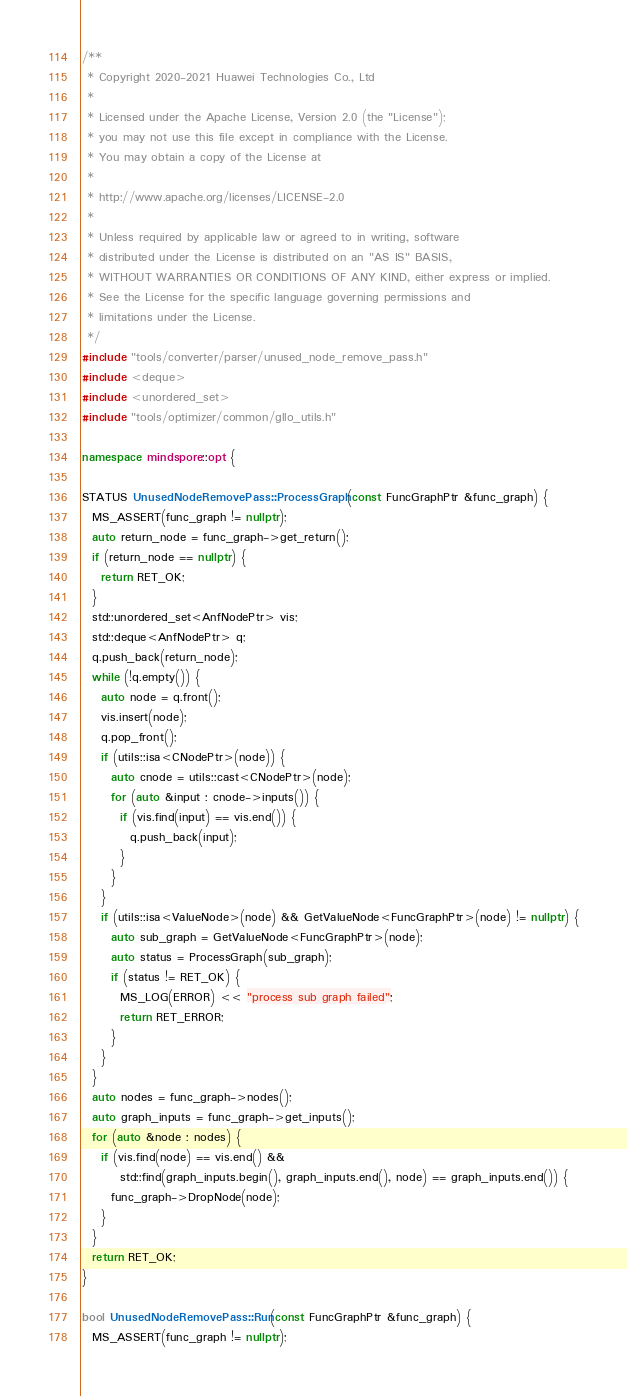Convert code to text. <code><loc_0><loc_0><loc_500><loc_500><_C++_>/**
 * Copyright 2020-2021 Huawei Technologies Co., Ltd
 *
 * Licensed under the Apache License, Version 2.0 (the "License");
 * you may not use this file except in compliance with the License.
 * You may obtain a copy of the License at
 *
 * http://www.apache.org/licenses/LICENSE-2.0
 *
 * Unless required by applicable law or agreed to in writing, software
 * distributed under the License is distributed on an "AS IS" BASIS,
 * WITHOUT WARRANTIES OR CONDITIONS OF ANY KIND, either express or implied.
 * See the License for the specific language governing permissions and
 * limitations under the License.
 */
#include "tools/converter/parser/unused_node_remove_pass.h"
#include <deque>
#include <unordered_set>
#include "tools/optimizer/common/gllo_utils.h"

namespace mindspore::opt {

STATUS UnusedNodeRemovePass::ProcessGraph(const FuncGraphPtr &func_graph) {
  MS_ASSERT(func_graph != nullptr);
  auto return_node = func_graph->get_return();
  if (return_node == nullptr) {
    return RET_OK;
  }
  std::unordered_set<AnfNodePtr> vis;
  std::deque<AnfNodePtr> q;
  q.push_back(return_node);
  while (!q.empty()) {
    auto node = q.front();
    vis.insert(node);
    q.pop_front();
    if (utils::isa<CNodePtr>(node)) {
      auto cnode = utils::cast<CNodePtr>(node);
      for (auto &input : cnode->inputs()) {
        if (vis.find(input) == vis.end()) {
          q.push_back(input);
        }
      }
    }
    if (utils::isa<ValueNode>(node) && GetValueNode<FuncGraphPtr>(node) != nullptr) {
      auto sub_graph = GetValueNode<FuncGraphPtr>(node);
      auto status = ProcessGraph(sub_graph);
      if (status != RET_OK) {
        MS_LOG(ERROR) << "process sub graph failed";
        return RET_ERROR;
      }
    }
  }
  auto nodes = func_graph->nodes();
  auto graph_inputs = func_graph->get_inputs();
  for (auto &node : nodes) {
    if (vis.find(node) == vis.end() &&
        std::find(graph_inputs.begin(), graph_inputs.end(), node) == graph_inputs.end()) {
      func_graph->DropNode(node);
    }
  }
  return RET_OK;
}

bool UnusedNodeRemovePass::Run(const FuncGraphPtr &func_graph) {
  MS_ASSERT(func_graph != nullptr);</code> 